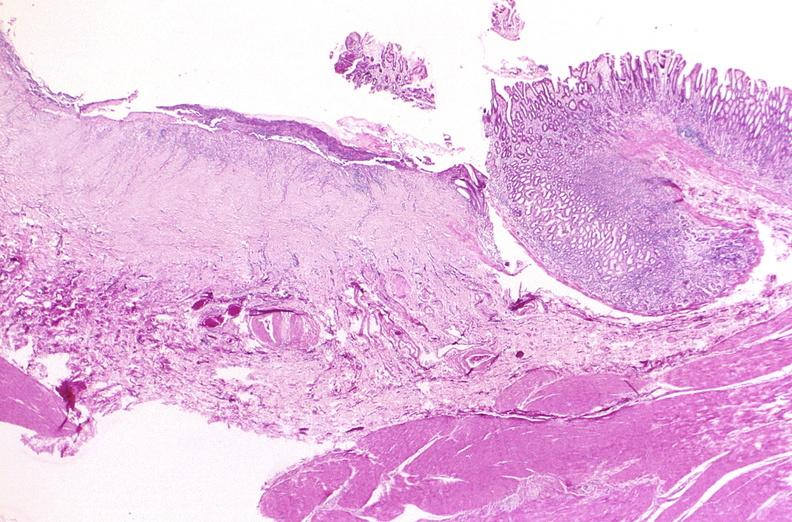what does this image show?
Answer the question using a single word or phrase. Stomach 